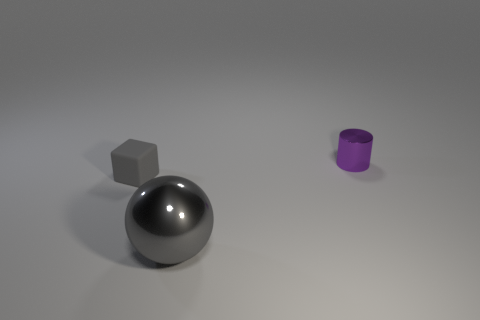Is the tiny object that is to the right of the gray metal thing made of the same material as the object that is to the left of the large sphere?
Your response must be concise. No. There is a metal thing left of the thing that is behind the gray matte object; what size is it?
Provide a succinct answer. Large. There is a gray object that is behind the big shiny object; what is its material?
Provide a short and direct response. Rubber. How many objects are small things in front of the small purple shiny cylinder or tiny objects that are to the left of the purple cylinder?
Your answer should be very brief. 1. There is a tiny thing that is on the left side of the large gray metal ball; is its color the same as the metal object that is to the right of the large gray sphere?
Offer a very short reply. No. Is there a red ball that has the same size as the cylinder?
Your answer should be compact. No. The object that is both left of the purple metallic cylinder and to the right of the block is made of what material?
Ensure brevity in your answer.  Metal. How many metal objects are blocks or big gray things?
Offer a terse response. 1. What shape is the small purple object that is made of the same material as the big gray sphere?
Provide a succinct answer. Cylinder. What number of tiny objects are right of the gray ball and on the left side of the small purple shiny object?
Your response must be concise. 0. 